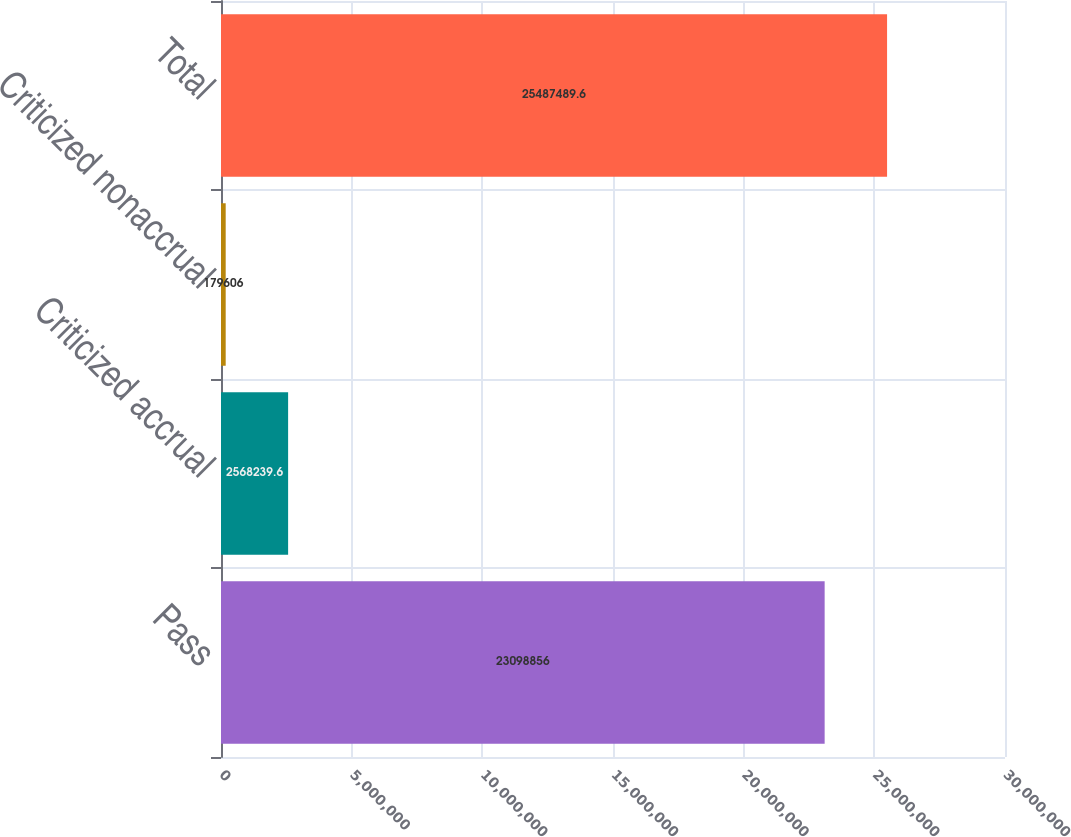Convert chart. <chart><loc_0><loc_0><loc_500><loc_500><bar_chart><fcel>Pass<fcel>Criticized accrual<fcel>Criticized nonaccrual<fcel>Total<nl><fcel>2.30989e+07<fcel>2.56824e+06<fcel>179606<fcel>2.54875e+07<nl></chart> 